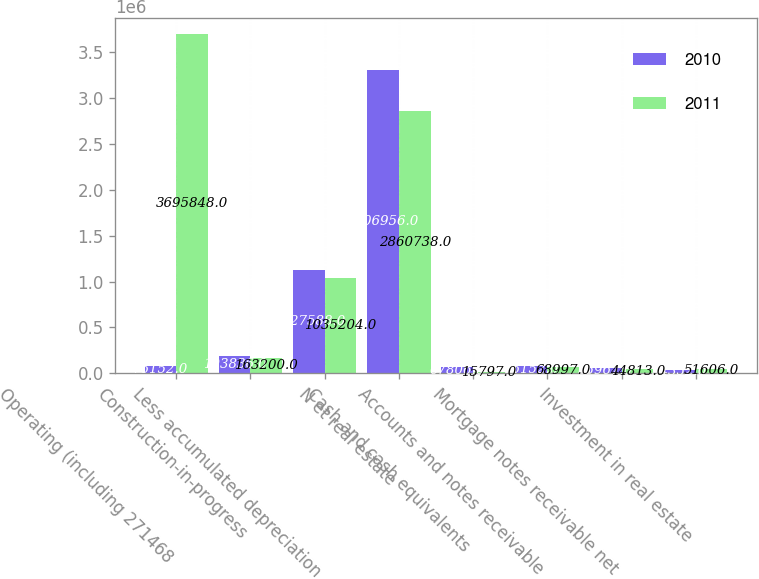<chart> <loc_0><loc_0><loc_500><loc_500><stacked_bar_chart><ecel><fcel>Operating (including 271468<fcel>Construction-in-progress<fcel>Less accumulated depreciation<fcel>N et real estate<fcel>Cash and cash equivalents<fcel>Accounts and notes receivable<fcel>Mortgage notes receivable net<fcel>Investment in real estate<nl><fcel>2010<fcel>76152<fcel>193836<fcel>1.12759e+06<fcel>3.30696e+06<fcel>67806<fcel>76152<fcel>55967<fcel>34352<nl><fcel>2011<fcel>3.69585e+06<fcel>163200<fcel>1.0352e+06<fcel>2.86074e+06<fcel>15797<fcel>68997<fcel>44813<fcel>51606<nl></chart> 